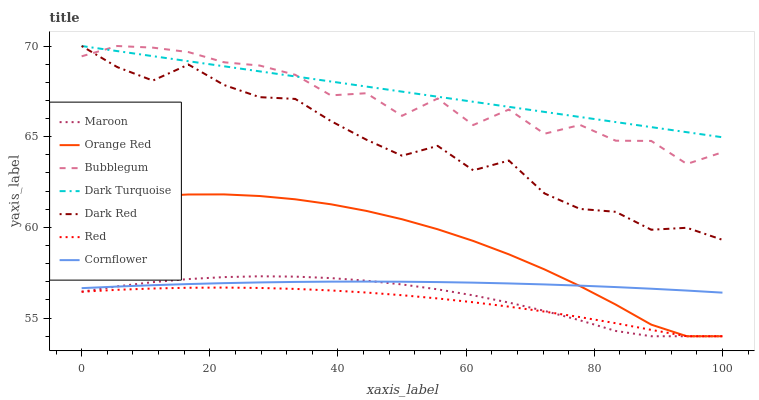Does Red have the minimum area under the curve?
Answer yes or no. Yes. Does Dark Turquoise have the maximum area under the curve?
Answer yes or no. Yes. Does Bubblegum have the minimum area under the curve?
Answer yes or no. No. Does Bubblegum have the maximum area under the curve?
Answer yes or no. No. Is Dark Turquoise the smoothest?
Answer yes or no. Yes. Is Bubblegum the roughest?
Answer yes or no. Yes. Is Bubblegum the smoothest?
Answer yes or no. No. Is Dark Turquoise the roughest?
Answer yes or no. No. Does Maroon have the lowest value?
Answer yes or no. Yes. Does Bubblegum have the lowest value?
Answer yes or no. No. Does Dark Red have the highest value?
Answer yes or no. Yes. Does Maroon have the highest value?
Answer yes or no. No. Is Cornflower less than Bubblegum?
Answer yes or no. Yes. Is Dark Turquoise greater than Orange Red?
Answer yes or no. Yes. Does Maroon intersect Orange Red?
Answer yes or no. Yes. Is Maroon less than Orange Red?
Answer yes or no. No. Is Maroon greater than Orange Red?
Answer yes or no. No. Does Cornflower intersect Bubblegum?
Answer yes or no. No. 